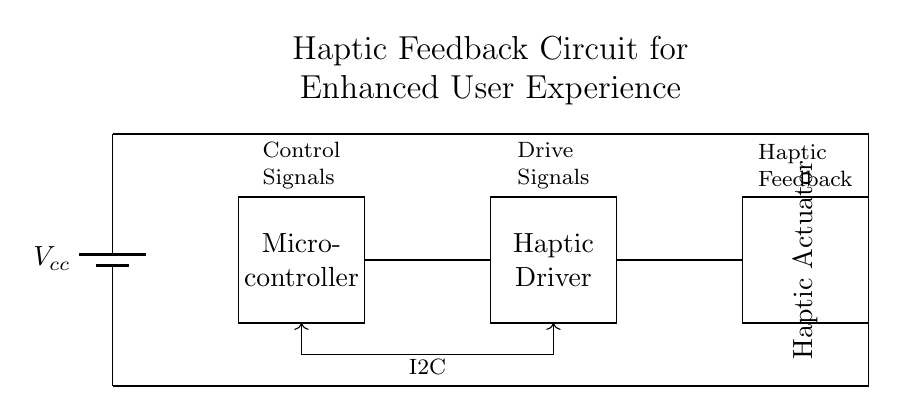What is the function of the microcontroller? The microcontroller serves as the control unit in the circuit, interpreting user inputs and generating control signals for the haptic driver.
Answer: Control unit What type of signals does the microcontroller send to the haptic driver? The microcontroller sends control signals to the haptic driver via an I2C interface, allowing it to communicate the desired haptic feedback effects.
Answer: Control signals What is the purpose of the haptic actuator? The haptic actuator converts electrical drive signals from the haptic driver into physical vibrations, enhancing the user experience with tactile feedback.
Answer: Physical vibrations How are the haptic driver and actuator connected? The haptic driver and actuator are connected in series, where the driver sends the appropriate drive signals to the actuator for operation.
Answer: In series What communication protocol is used between the microcontroller and haptic driver? The protocol used for communication is I2C, which facilitates efficient data exchange between the microcontroller and the haptic driver.
Answer: I2C Why is there a battery included in the circuit? The battery provides the necessary power supply for all components within the circuit, ensuring they operate effectively for the intended user experience.
Answer: Power supply 